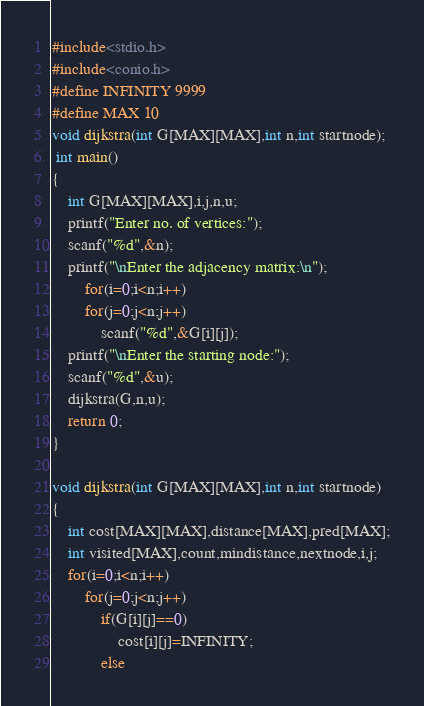<code> <loc_0><loc_0><loc_500><loc_500><_C_>#include<stdio.h>
#include<conio.h>
#define INFINITY 9999
#define MAX 10
void dijkstra(int G[MAX][MAX],int n,int startnode);
 int main()
{
	int G[MAX][MAX],i,j,n,u;
	printf("Enter no. of vertices:");
	scanf("%d",&n);
	printf("\nEnter the adjacency matrix:\n");
		for(i=0;i<n;i++)
		for(j=0;j<n;j++)
			scanf("%d",&G[i][j]);
	printf("\nEnter the starting node:");
	scanf("%d",&u);
	dijkstra(G,n,u);
	return 0;
}

void dijkstra(int G[MAX][MAX],int n,int startnode)
{
	int cost[MAX][MAX],distance[MAX],pred[MAX];
	int visited[MAX],count,mindistance,nextnode,i,j;
	for(i=0;i<n;i++)
		for(j=0;j<n;j++)
			if(G[i][j]==0)
				cost[i][j]=INFINITY;
			else</code> 